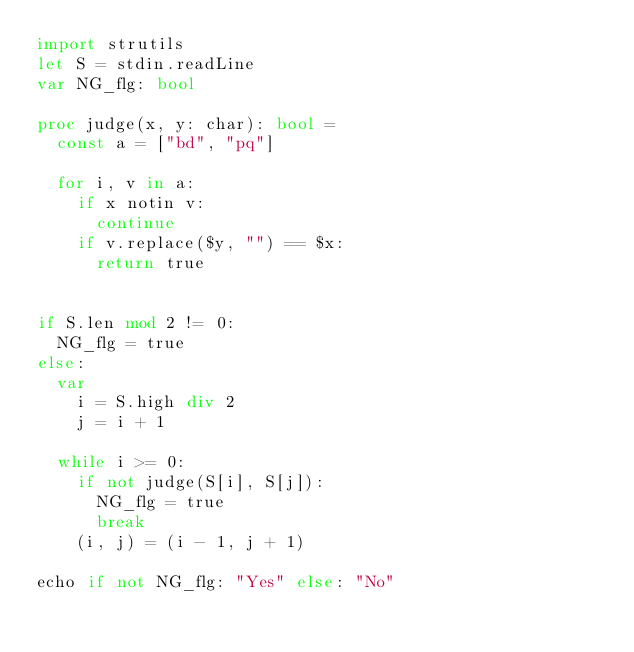Convert code to text. <code><loc_0><loc_0><loc_500><loc_500><_Nim_>import strutils
let S = stdin.readLine
var NG_flg: bool

proc judge(x, y: char): bool =
  const a = ["bd", "pq"]

  for i, v in a:
    if x notin v:
      continue
    if v.replace($y, "") == $x:
      return true


if S.len mod 2 != 0:
  NG_flg = true
else:
  var
    i = S.high div 2
    j = i + 1

  while i >= 0:
    if not judge(S[i], S[j]):
      NG_flg = true
      break
    (i, j) = (i - 1, j + 1)

echo if not NG_flg: "Yes" else: "No"
</code> 